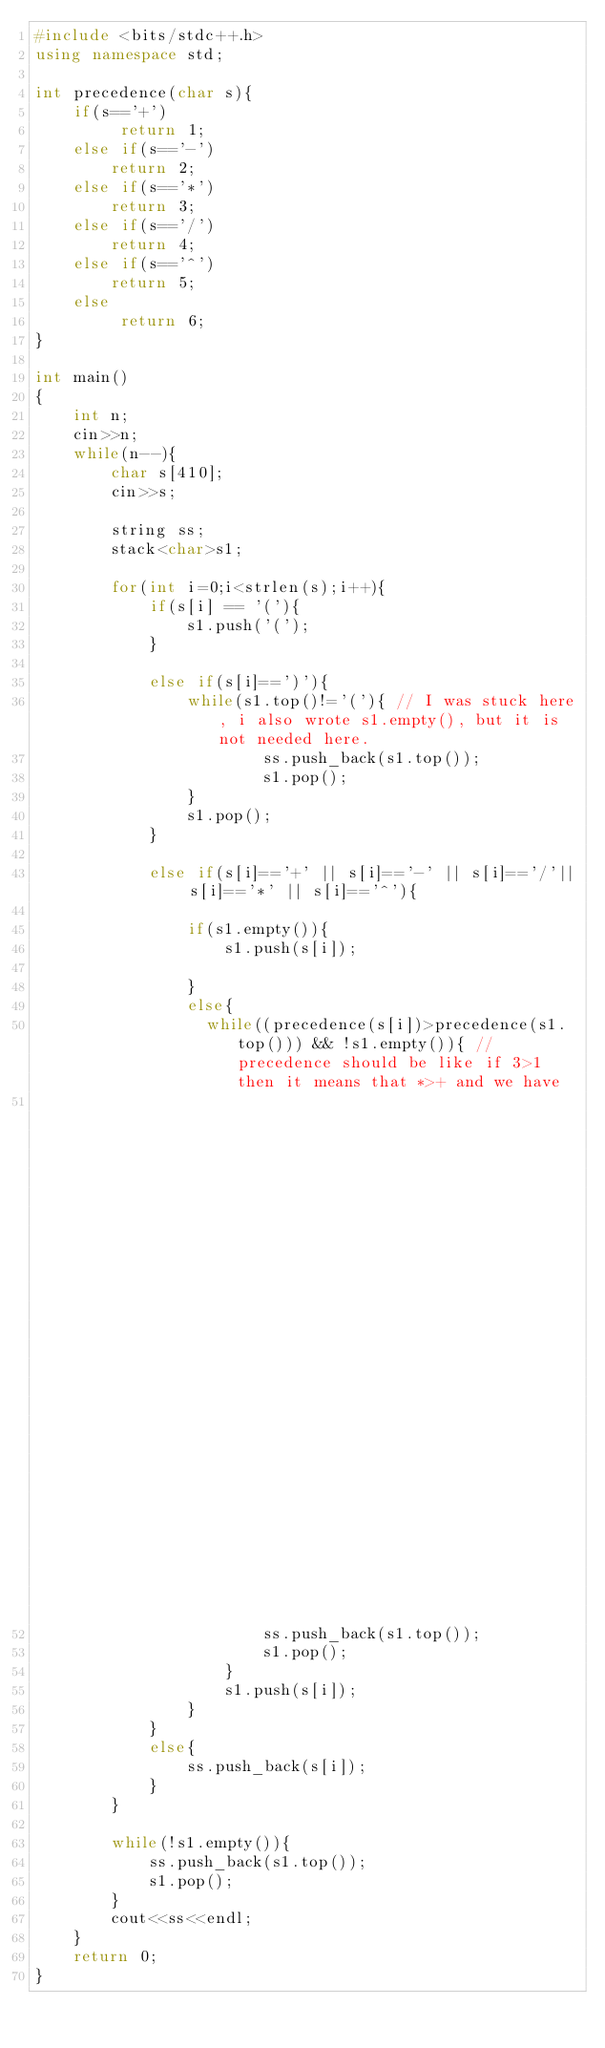<code> <loc_0><loc_0><loc_500><loc_500><_C++_>#include <bits/stdc++.h>
using namespace std;

int precedence(char s){
    if(s=='+')
         return 1;
    else if(s=='-')
        return 2;
    else if(s=='*')
        return 3;
    else if(s=='/')
        return 4;
    else if(s=='^')
        return 5;
    else
         return 6;
}

int main()
{
    int n;
    cin>>n;
    while(n--){
        char s[410];
        cin>>s;

        string ss;
        stack<char>s1;

        for(int i=0;i<strlen(s);i++){
            if(s[i] == '('){
                s1.push('(');
            }

            else if(s[i]==')'){
                while(s1.top()!='('){ // I was stuck here, i also wrote s1.empty(), but it is not needed here.
                        ss.push_back(s1.top());
                        s1.pop();
                }
                s1.pop();
            }

            else if(s[i]=='+' || s[i]=='-' || s[i]=='/'|| s[i]=='*' || s[i]=='^'){

                if(s1.empty()){
                    s1.push(s[i]);

                }
                else{
                  while((precedence(s[i])>precedence(s1.top())) && !s1.empty()){ // precedence should be like if 3>1 then it means that *>+ and we have
                                                                                 // pop out elements unless we found operator which has greater or equal precedence
                        ss.push_back(s1.top());
                        s1.pop();
                    }
                    s1.push(s[i]);
                }
            }
            else{
                ss.push_back(s[i]);
            }
        }

        while(!s1.empty()){
            ss.push_back(s1.top());
            s1.pop();
        }
        cout<<ss<<endl;
    }
    return 0;
}
</code> 